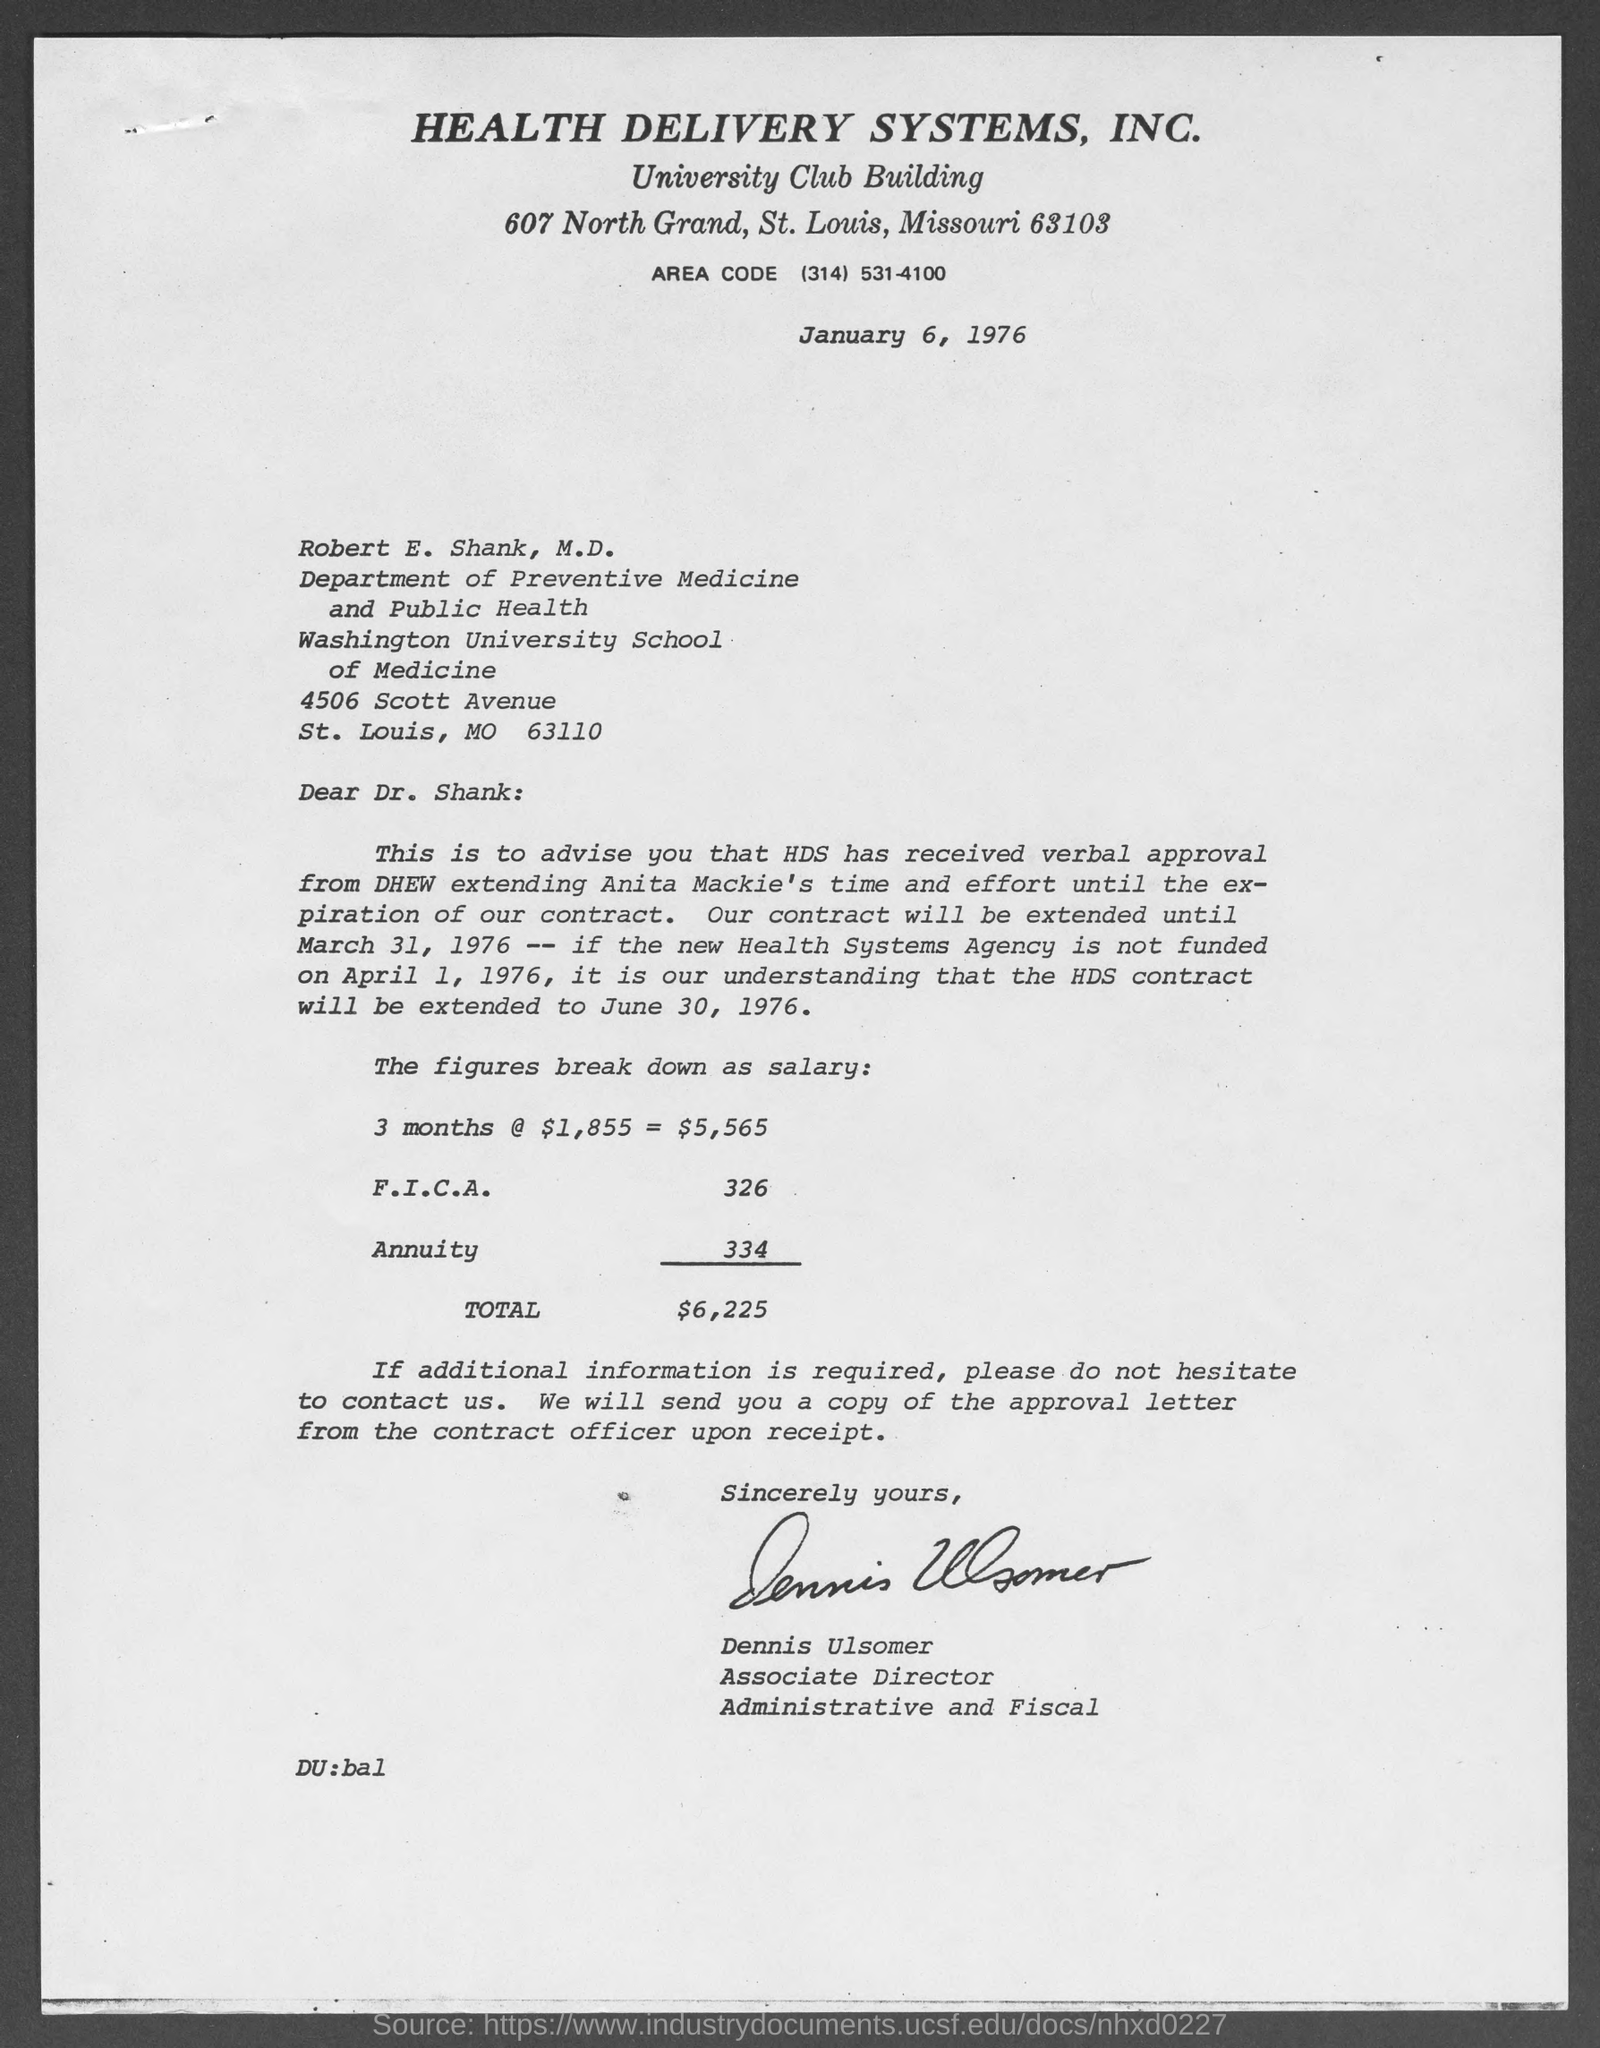What is Area Code?
Offer a very short reply. Area Code (314) 531-4100. What is the date mentioned in the top of the document ?
Your answer should be very brief. January 6, 1976. How much Annuity ?
Provide a succinct answer. 334. Who is the Associate Director ?
Provide a succinct answer. Dennis Ulsomer. 